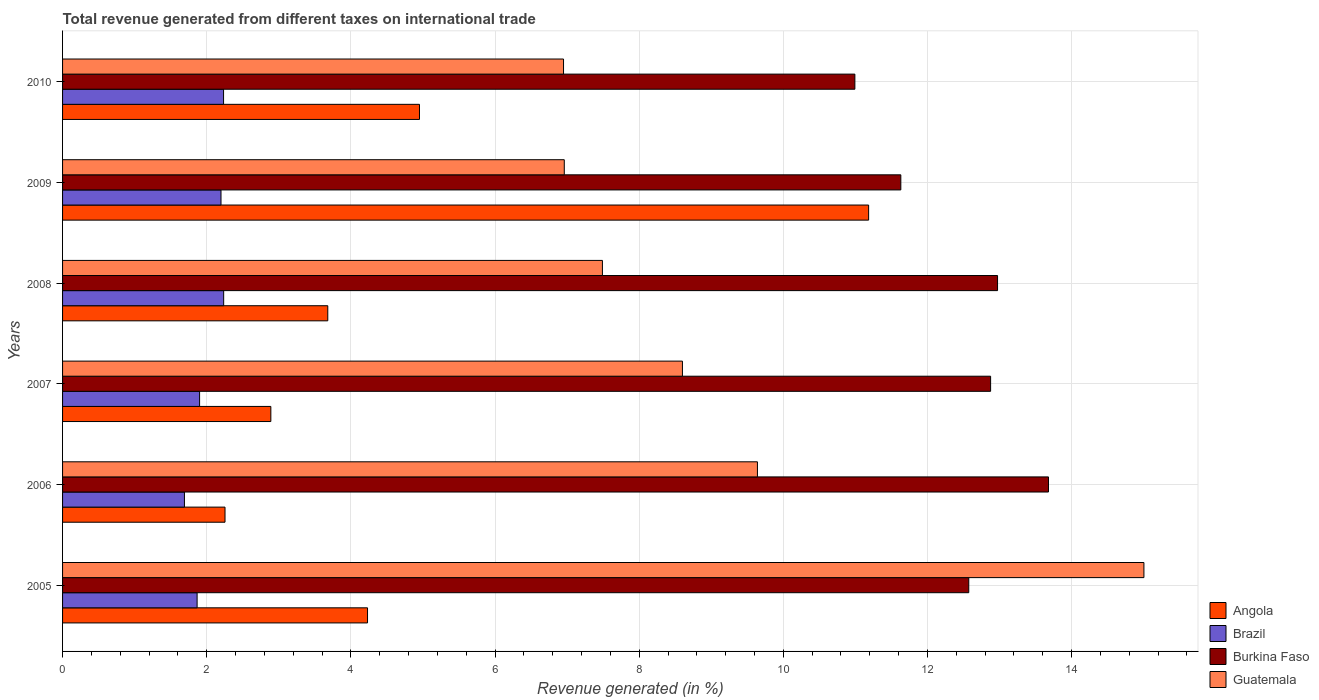How many groups of bars are there?
Your answer should be compact. 6. Are the number of bars per tick equal to the number of legend labels?
Offer a very short reply. Yes. Are the number of bars on each tick of the Y-axis equal?
Give a very brief answer. Yes. What is the label of the 6th group of bars from the top?
Ensure brevity in your answer.  2005. What is the total revenue generated in Angola in 2006?
Provide a succinct answer. 2.25. Across all years, what is the maximum total revenue generated in Brazil?
Your answer should be compact. 2.24. Across all years, what is the minimum total revenue generated in Brazil?
Provide a short and direct response. 1.69. In which year was the total revenue generated in Angola maximum?
Your answer should be very brief. 2009. In which year was the total revenue generated in Guatemala minimum?
Your answer should be very brief. 2010. What is the total total revenue generated in Guatemala in the graph?
Your answer should be very brief. 54.65. What is the difference between the total revenue generated in Angola in 2005 and that in 2007?
Your answer should be very brief. 1.34. What is the difference between the total revenue generated in Burkina Faso in 2009 and the total revenue generated in Brazil in 2008?
Make the answer very short. 9.39. What is the average total revenue generated in Burkina Faso per year?
Make the answer very short. 12.45. In the year 2009, what is the difference between the total revenue generated in Angola and total revenue generated in Burkina Faso?
Make the answer very short. -0.45. In how many years, is the total revenue generated in Brazil greater than 8.8 %?
Give a very brief answer. 0. What is the ratio of the total revenue generated in Burkina Faso in 2005 to that in 2009?
Provide a succinct answer. 1.08. Is the total revenue generated in Angola in 2006 less than that in 2009?
Your answer should be very brief. Yes. Is the difference between the total revenue generated in Angola in 2006 and 2010 greater than the difference between the total revenue generated in Burkina Faso in 2006 and 2010?
Offer a very short reply. No. What is the difference between the highest and the second highest total revenue generated in Brazil?
Offer a terse response. 0. What is the difference between the highest and the lowest total revenue generated in Angola?
Keep it short and to the point. 8.93. Is the sum of the total revenue generated in Burkina Faso in 2005 and 2008 greater than the maximum total revenue generated in Brazil across all years?
Your answer should be compact. Yes. Is it the case that in every year, the sum of the total revenue generated in Brazil and total revenue generated in Burkina Faso is greater than the sum of total revenue generated in Guatemala and total revenue generated in Angola?
Provide a succinct answer. No. What does the 2nd bar from the top in 2006 represents?
Ensure brevity in your answer.  Burkina Faso. What does the 3rd bar from the bottom in 2009 represents?
Your response must be concise. Burkina Faso. Is it the case that in every year, the sum of the total revenue generated in Angola and total revenue generated in Burkina Faso is greater than the total revenue generated in Guatemala?
Ensure brevity in your answer.  Yes. How many bars are there?
Offer a terse response. 24. Are the values on the major ticks of X-axis written in scientific E-notation?
Offer a very short reply. No. Does the graph contain any zero values?
Give a very brief answer. No. Does the graph contain grids?
Provide a succinct answer. Yes. Where does the legend appear in the graph?
Offer a very short reply. Bottom right. What is the title of the graph?
Provide a succinct answer. Total revenue generated from different taxes on international trade. What is the label or title of the X-axis?
Make the answer very short. Revenue generated (in %). What is the Revenue generated (in %) in Angola in 2005?
Make the answer very short. 4.23. What is the Revenue generated (in %) of Brazil in 2005?
Your response must be concise. 1.87. What is the Revenue generated (in %) in Burkina Faso in 2005?
Give a very brief answer. 12.57. What is the Revenue generated (in %) in Guatemala in 2005?
Keep it short and to the point. 15. What is the Revenue generated (in %) of Angola in 2006?
Your response must be concise. 2.25. What is the Revenue generated (in %) in Brazil in 2006?
Your response must be concise. 1.69. What is the Revenue generated (in %) of Burkina Faso in 2006?
Keep it short and to the point. 13.68. What is the Revenue generated (in %) in Guatemala in 2006?
Offer a very short reply. 9.64. What is the Revenue generated (in %) in Angola in 2007?
Ensure brevity in your answer.  2.89. What is the Revenue generated (in %) of Brazil in 2007?
Provide a succinct answer. 1.9. What is the Revenue generated (in %) in Burkina Faso in 2007?
Your answer should be compact. 12.88. What is the Revenue generated (in %) in Guatemala in 2007?
Your answer should be very brief. 8.6. What is the Revenue generated (in %) of Angola in 2008?
Your response must be concise. 3.68. What is the Revenue generated (in %) of Brazil in 2008?
Ensure brevity in your answer.  2.24. What is the Revenue generated (in %) of Burkina Faso in 2008?
Offer a very short reply. 12.97. What is the Revenue generated (in %) of Guatemala in 2008?
Offer a very short reply. 7.49. What is the Revenue generated (in %) in Angola in 2009?
Make the answer very short. 11.18. What is the Revenue generated (in %) in Brazil in 2009?
Offer a terse response. 2.2. What is the Revenue generated (in %) of Burkina Faso in 2009?
Your response must be concise. 11.63. What is the Revenue generated (in %) in Guatemala in 2009?
Offer a very short reply. 6.96. What is the Revenue generated (in %) of Angola in 2010?
Your answer should be very brief. 4.95. What is the Revenue generated (in %) in Brazil in 2010?
Your answer should be very brief. 2.23. What is the Revenue generated (in %) of Burkina Faso in 2010?
Give a very brief answer. 10.99. What is the Revenue generated (in %) of Guatemala in 2010?
Provide a succinct answer. 6.95. Across all years, what is the maximum Revenue generated (in %) in Angola?
Offer a terse response. 11.18. Across all years, what is the maximum Revenue generated (in %) of Brazil?
Ensure brevity in your answer.  2.24. Across all years, what is the maximum Revenue generated (in %) of Burkina Faso?
Your answer should be very brief. 13.68. Across all years, what is the maximum Revenue generated (in %) in Guatemala?
Provide a short and direct response. 15. Across all years, what is the minimum Revenue generated (in %) of Angola?
Provide a short and direct response. 2.25. Across all years, what is the minimum Revenue generated (in %) in Brazil?
Your response must be concise. 1.69. Across all years, what is the minimum Revenue generated (in %) of Burkina Faso?
Ensure brevity in your answer.  10.99. Across all years, what is the minimum Revenue generated (in %) in Guatemala?
Make the answer very short. 6.95. What is the total Revenue generated (in %) in Angola in the graph?
Offer a very short reply. 29.19. What is the total Revenue generated (in %) of Brazil in the graph?
Ensure brevity in your answer.  12.13. What is the total Revenue generated (in %) in Burkina Faso in the graph?
Provide a short and direct response. 74.72. What is the total Revenue generated (in %) in Guatemala in the graph?
Ensure brevity in your answer.  54.65. What is the difference between the Revenue generated (in %) in Angola in 2005 and that in 2006?
Keep it short and to the point. 1.98. What is the difference between the Revenue generated (in %) of Brazil in 2005 and that in 2006?
Your answer should be very brief. 0.18. What is the difference between the Revenue generated (in %) of Burkina Faso in 2005 and that in 2006?
Give a very brief answer. -1.11. What is the difference between the Revenue generated (in %) of Guatemala in 2005 and that in 2006?
Your response must be concise. 5.36. What is the difference between the Revenue generated (in %) in Angola in 2005 and that in 2007?
Your answer should be very brief. 1.34. What is the difference between the Revenue generated (in %) of Brazil in 2005 and that in 2007?
Your response must be concise. -0.03. What is the difference between the Revenue generated (in %) of Burkina Faso in 2005 and that in 2007?
Provide a short and direct response. -0.3. What is the difference between the Revenue generated (in %) of Guatemala in 2005 and that in 2007?
Your answer should be very brief. 6.4. What is the difference between the Revenue generated (in %) in Angola in 2005 and that in 2008?
Your answer should be very brief. 0.55. What is the difference between the Revenue generated (in %) of Brazil in 2005 and that in 2008?
Your answer should be compact. -0.37. What is the difference between the Revenue generated (in %) in Burkina Faso in 2005 and that in 2008?
Provide a succinct answer. -0.4. What is the difference between the Revenue generated (in %) in Guatemala in 2005 and that in 2008?
Ensure brevity in your answer.  7.51. What is the difference between the Revenue generated (in %) of Angola in 2005 and that in 2009?
Give a very brief answer. -6.95. What is the difference between the Revenue generated (in %) of Brazil in 2005 and that in 2009?
Keep it short and to the point. -0.33. What is the difference between the Revenue generated (in %) of Burkina Faso in 2005 and that in 2009?
Give a very brief answer. 0.94. What is the difference between the Revenue generated (in %) in Guatemala in 2005 and that in 2009?
Ensure brevity in your answer.  8.04. What is the difference between the Revenue generated (in %) in Angola in 2005 and that in 2010?
Offer a terse response. -0.72. What is the difference between the Revenue generated (in %) in Brazil in 2005 and that in 2010?
Your response must be concise. -0.37. What is the difference between the Revenue generated (in %) of Burkina Faso in 2005 and that in 2010?
Offer a very short reply. 1.58. What is the difference between the Revenue generated (in %) of Guatemala in 2005 and that in 2010?
Offer a terse response. 8.05. What is the difference between the Revenue generated (in %) in Angola in 2006 and that in 2007?
Make the answer very short. -0.64. What is the difference between the Revenue generated (in %) of Brazil in 2006 and that in 2007?
Make the answer very short. -0.21. What is the difference between the Revenue generated (in %) in Burkina Faso in 2006 and that in 2007?
Make the answer very short. 0.8. What is the difference between the Revenue generated (in %) in Guatemala in 2006 and that in 2007?
Your response must be concise. 1.04. What is the difference between the Revenue generated (in %) of Angola in 2006 and that in 2008?
Your response must be concise. -1.43. What is the difference between the Revenue generated (in %) of Brazil in 2006 and that in 2008?
Keep it short and to the point. -0.54. What is the difference between the Revenue generated (in %) in Burkina Faso in 2006 and that in 2008?
Your response must be concise. 0.71. What is the difference between the Revenue generated (in %) in Guatemala in 2006 and that in 2008?
Keep it short and to the point. 2.15. What is the difference between the Revenue generated (in %) in Angola in 2006 and that in 2009?
Keep it short and to the point. -8.93. What is the difference between the Revenue generated (in %) of Brazil in 2006 and that in 2009?
Your answer should be very brief. -0.51. What is the difference between the Revenue generated (in %) of Burkina Faso in 2006 and that in 2009?
Your response must be concise. 2.05. What is the difference between the Revenue generated (in %) of Guatemala in 2006 and that in 2009?
Provide a short and direct response. 2.68. What is the difference between the Revenue generated (in %) in Angola in 2006 and that in 2010?
Offer a terse response. -2.7. What is the difference between the Revenue generated (in %) in Brazil in 2006 and that in 2010?
Offer a terse response. -0.54. What is the difference between the Revenue generated (in %) of Burkina Faso in 2006 and that in 2010?
Provide a succinct answer. 2.69. What is the difference between the Revenue generated (in %) of Guatemala in 2006 and that in 2010?
Make the answer very short. 2.69. What is the difference between the Revenue generated (in %) in Angola in 2007 and that in 2008?
Your answer should be very brief. -0.79. What is the difference between the Revenue generated (in %) in Brazil in 2007 and that in 2008?
Give a very brief answer. -0.33. What is the difference between the Revenue generated (in %) of Burkina Faso in 2007 and that in 2008?
Give a very brief answer. -0.1. What is the difference between the Revenue generated (in %) in Guatemala in 2007 and that in 2008?
Give a very brief answer. 1.11. What is the difference between the Revenue generated (in %) in Angola in 2007 and that in 2009?
Make the answer very short. -8.29. What is the difference between the Revenue generated (in %) of Brazil in 2007 and that in 2009?
Keep it short and to the point. -0.3. What is the difference between the Revenue generated (in %) of Burkina Faso in 2007 and that in 2009?
Provide a succinct answer. 1.25. What is the difference between the Revenue generated (in %) of Guatemala in 2007 and that in 2009?
Make the answer very short. 1.64. What is the difference between the Revenue generated (in %) in Angola in 2007 and that in 2010?
Give a very brief answer. -2.06. What is the difference between the Revenue generated (in %) of Brazil in 2007 and that in 2010?
Keep it short and to the point. -0.33. What is the difference between the Revenue generated (in %) of Burkina Faso in 2007 and that in 2010?
Your answer should be very brief. 1.88. What is the difference between the Revenue generated (in %) of Guatemala in 2007 and that in 2010?
Make the answer very short. 1.65. What is the difference between the Revenue generated (in %) in Angola in 2008 and that in 2009?
Make the answer very short. -7.5. What is the difference between the Revenue generated (in %) in Brazil in 2008 and that in 2009?
Keep it short and to the point. 0.04. What is the difference between the Revenue generated (in %) in Burkina Faso in 2008 and that in 2009?
Keep it short and to the point. 1.34. What is the difference between the Revenue generated (in %) of Guatemala in 2008 and that in 2009?
Provide a succinct answer. 0.53. What is the difference between the Revenue generated (in %) in Angola in 2008 and that in 2010?
Ensure brevity in your answer.  -1.27. What is the difference between the Revenue generated (in %) in Brazil in 2008 and that in 2010?
Your answer should be compact. 0. What is the difference between the Revenue generated (in %) of Burkina Faso in 2008 and that in 2010?
Provide a succinct answer. 1.98. What is the difference between the Revenue generated (in %) of Guatemala in 2008 and that in 2010?
Give a very brief answer. 0.54. What is the difference between the Revenue generated (in %) of Angola in 2009 and that in 2010?
Ensure brevity in your answer.  6.23. What is the difference between the Revenue generated (in %) of Brazil in 2009 and that in 2010?
Provide a succinct answer. -0.04. What is the difference between the Revenue generated (in %) of Burkina Faso in 2009 and that in 2010?
Ensure brevity in your answer.  0.64. What is the difference between the Revenue generated (in %) of Guatemala in 2009 and that in 2010?
Provide a succinct answer. 0.01. What is the difference between the Revenue generated (in %) in Angola in 2005 and the Revenue generated (in %) in Brazil in 2006?
Provide a short and direct response. 2.54. What is the difference between the Revenue generated (in %) in Angola in 2005 and the Revenue generated (in %) in Burkina Faso in 2006?
Offer a terse response. -9.45. What is the difference between the Revenue generated (in %) of Angola in 2005 and the Revenue generated (in %) of Guatemala in 2006?
Provide a succinct answer. -5.41. What is the difference between the Revenue generated (in %) of Brazil in 2005 and the Revenue generated (in %) of Burkina Faso in 2006?
Offer a terse response. -11.81. What is the difference between the Revenue generated (in %) in Brazil in 2005 and the Revenue generated (in %) in Guatemala in 2006?
Provide a short and direct response. -7.77. What is the difference between the Revenue generated (in %) in Burkina Faso in 2005 and the Revenue generated (in %) in Guatemala in 2006?
Ensure brevity in your answer.  2.93. What is the difference between the Revenue generated (in %) of Angola in 2005 and the Revenue generated (in %) of Brazil in 2007?
Your answer should be compact. 2.33. What is the difference between the Revenue generated (in %) of Angola in 2005 and the Revenue generated (in %) of Burkina Faso in 2007?
Give a very brief answer. -8.64. What is the difference between the Revenue generated (in %) of Angola in 2005 and the Revenue generated (in %) of Guatemala in 2007?
Provide a succinct answer. -4.37. What is the difference between the Revenue generated (in %) of Brazil in 2005 and the Revenue generated (in %) of Burkina Faso in 2007?
Provide a succinct answer. -11.01. What is the difference between the Revenue generated (in %) of Brazil in 2005 and the Revenue generated (in %) of Guatemala in 2007?
Provide a short and direct response. -6.73. What is the difference between the Revenue generated (in %) in Burkina Faso in 2005 and the Revenue generated (in %) in Guatemala in 2007?
Ensure brevity in your answer.  3.97. What is the difference between the Revenue generated (in %) of Angola in 2005 and the Revenue generated (in %) of Brazil in 2008?
Provide a short and direct response. 2. What is the difference between the Revenue generated (in %) of Angola in 2005 and the Revenue generated (in %) of Burkina Faso in 2008?
Ensure brevity in your answer.  -8.74. What is the difference between the Revenue generated (in %) of Angola in 2005 and the Revenue generated (in %) of Guatemala in 2008?
Keep it short and to the point. -3.26. What is the difference between the Revenue generated (in %) in Brazil in 2005 and the Revenue generated (in %) in Burkina Faso in 2008?
Your answer should be very brief. -11.11. What is the difference between the Revenue generated (in %) in Brazil in 2005 and the Revenue generated (in %) in Guatemala in 2008?
Provide a succinct answer. -5.62. What is the difference between the Revenue generated (in %) of Burkina Faso in 2005 and the Revenue generated (in %) of Guatemala in 2008?
Your answer should be very brief. 5.08. What is the difference between the Revenue generated (in %) in Angola in 2005 and the Revenue generated (in %) in Brazil in 2009?
Make the answer very short. 2.03. What is the difference between the Revenue generated (in %) of Angola in 2005 and the Revenue generated (in %) of Burkina Faso in 2009?
Provide a short and direct response. -7.4. What is the difference between the Revenue generated (in %) in Angola in 2005 and the Revenue generated (in %) in Guatemala in 2009?
Keep it short and to the point. -2.73. What is the difference between the Revenue generated (in %) in Brazil in 2005 and the Revenue generated (in %) in Burkina Faso in 2009?
Your answer should be compact. -9.76. What is the difference between the Revenue generated (in %) in Brazil in 2005 and the Revenue generated (in %) in Guatemala in 2009?
Keep it short and to the point. -5.09. What is the difference between the Revenue generated (in %) in Burkina Faso in 2005 and the Revenue generated (in %) in Guatemala in 2009?
Ensure brevity in your answer.  5.61. What is the difference between the Revenue generated (in %) of Angola in 2005 and the Revenue generated (in %) of Brazil in 2010?
Your response must be concise. 2. What is the difference between the Revenue generated (in %) of Angola in 2005 and the Revenue generated (in %) of Burkina Faso in 2010?
Your answer should be very brief. -6.76. What is the difference between the Revenue generated (in %) in Angola in 2005 and the Revenue generated (in %) in Guatemala in 2010?
Keep it short and to the point. -2.72. What is the difference between the Revenue generated (in %) in Brazil in 2005 and the Revenue generated (in %) in Burkina Faso in 2010?
Offer a very short reply. -9.13. What is the difference between the Revenue generated (in %) in Brazil in 2005 and the Revenue generated (in %) in Guatemala in 2010?
Your answer should be very brief. -5.08. What is the difference between the Revenue generated (in %) of Burkina Faso in 2005 and the Revenue generated (in %) of Guatemala in 2010?
Provide a succinct answer. 5.62. What is the difference between the Revenue generated (in %) in Angola in 2006 and the Revenue generated (in %) in Brazil in 2007?
Keep it short and to the point. 0.35. What is the difference between the Revenue generated (in %) of Angola in 2006 and the Revenue generated (in %) of Burkina Faso in 2007?
Give a very brief answer. -10.62. What is the difference between the Revenue generated (in %) in Angola in 2006 and the Revenue generated (in %) in Guatemala in 2007?
Keep it short and to the point. -6.35. What is the difference between the Revenue generated (in %) of Brazil in 2006 and the Revenue generated (in %) of Burkina Faso in 2007?
Provide a succinct answer. -11.18. What is the difference between the Revenue generated (in %) of Brazil in 2006 and the Revenue generated (in %) of Guatemala in 2007?
Your answer should be compact. -6.91. What is the difference between the Revenue generated (in %) of Burkina Faso in 2006 and the Revenue generated (in %) of Guatemala in 2007?
Offer a terse response. 5.08. What is the difference between the Revenue generated (in %) of Angola in 2006 and the Revenue generated (in %) of Brazil in 2008?
Ensure brevity in your answer.  0.02. What is the difference between the Revenue generated (in %) in Angola in 2006 and the Revenue generated (in %) in Burkina Faso in 2008?
Provide a succinct answer. -10.72. What is the difference between the Revenue generated (in %) in Angola in 2006 and the Revenue generated (in %) in Guatemala in 2008?
Offer a very short reply. -5.24. What is the difference between the Revenue generated (in %) of Brazil in 2006 and the Revenue generated (in %) of Burkina Faso in 2008?
Offer a very short reply. -11.28. What is the difference between the Revenue generated (in %) in Brazil in 2006 and the Revenue generated (in %) in Guatemala in 2008?
Offer a very short reply. -5.8. What is the difference between the Revenue generated (in %) in Burkina Faso in 2006 and the Revenue generated (in %) in Guatemala in 2008?
Keep it short and to the point. 6.19. What is the difference between the Revenue generated (in %) of Angola in 2006 and the Revenue generated (in %) of Brazil in 2009?
Ensure brevity in your answer.  0.06. What is the difference between the Revenue generated (in %) in Angola in 2006 and the Revenue generated (in %) in Burkina Faso in 2009?
Ensure brevity in your answer.  -9.38. What is the difference between the Revenue generated (in %) of Angola in 2006 and the Revenue generated (in %) of Guatemala in 2009?
Provide a short and direct response. -4.71. What is the difference between the Revenue generated (in %) of Brazil in 2006 and the Revenue generated (in %) of Burkina Faso in 2009?
Your answer should be compact. -9.94. What is the difference between the Revenue generated (in %) of Brazil in 2006 and the Revenue generated (in %) of Guatemala in 2009?
Your answer should be compact. -5.27. What is the difference between the Revenue generated (in %) of Burkina Faso in 2006 and the Revenue generated (in %) of Guatemala in 2009?
Provide a short and direct response. 6.72. What is the difference between the Revenue generated (in %) in Angola in 2006 and the Revenue generated (in %) in Brazil in 2010?
Offer a terse response. 0.02. What is the difference between the Revenue generated (in %) of Angola in 2006 and the Revenue generated (in %) of Burkina Faso in 2010?
Provide a succinct answer. -8.74. What is the difference between the Revenue generated (in %) in Angola in 2006 and the Revenue generated (in %) in Guatemala in 2010?
Provide a short and direct response. -4.7. What is the difference between the Revenue generated (in %) in Brazil in 2006 and the Revenue generated (in %) in Burkina Faso in 2010?
Give a very brief answer. -9.3. What is the difference between the Revenue generated (in %) of Brazil in 2006 and the Revenue generated (in %) of Guatemala in 2010?
Your answer should be compact. -5.26. What is the difference between the Revenue generated (in %) in Burkina Faso in 2006 and the Revenue generated (in %) in Guatemala in 2010?
Your answer should be compact. 6.73. What is the difference between the Revenue generated (in %) in Angola in 2007 and the Revenue generated (in %) in Brazil in 2008?
Make the answer very short. 0.65. What is the difference between the Revenue generated (in %) in Angola in 2007 and the Revenue generated (in %) in Burkina Faso in 2008?
Provide a succinct answer. -10.08. What is the difference between the Revenue generated (in %) in Angola in 2007 and the Revenue generated (in %) in Guatemala in 2008?
Offer a very short reply. -4.6. What is the difference between the Revenue generated (in %) of Brazil in 2007 and the Revenue generated (in %) of Burkina Faso in 2008?
Keep it short and to the point. -11.07. What is the difference between the Revenue generated (in %) in Brazil in 2007 and the Revenue generated (in %) in Guatemala in 2008?
Provide a short and direct response. -5.59. What is the difference between the Revenue generated (in %) in Burkina Faso in 2007 and the Revenue generated (in %) in Guatemala in 2008?
Ensure brevity in your answer.  5.39. What is the difference between the Revenue generated (in %) in Angola in 2007 and the Revenue generated (in %) in Brazil in 2009?
Provide a succinct answer. 0.69. What is the difference between the Revenue generated (in %) in Angola in 2007 and the Revenue generated (in %) in Burkina Faso in 2009?
Keep it short and to the point. -8.74. What is the difference between the Revenue generated (in %) of Angola in 2007 and the Revenue generated (in %) of Guatemala in 2009?
Your response must be concise. -4.07. What is the difference between the Revenue generated (in %) of Brazil in 2007 and the Revenue generated (in %) of Burkina Faso in 2009?
Your answer should be very brief. -9.73. What is the difference between the Revenue generated (in %) of Brazil in 2007 and the Revenue generated (in %) of Guatemala in 2009?
Offer a terse response. -5.06. What is the difference between the Revenue generated (in %) in Burkina Faso in 2007 and the Revenue generated (in %) in Guatemala in 2009?
Make the answer very short. 5.91. What is the difference between the Revenue generated (in %) in Angola in 2007 and the Revenue generated (in %) in Brazil in 2010?
Your response must be concise. 0.66. What is the difference between the Revenue generated (in %) of Angola in 2007 and the Revenue generated (in %) of Burkina Faso in 2010?
Provide a short and direct response. -8.1. What is the difference between the Revenue generated (in %) in Angola in 2007 and the Revenue generated (in %) in Guatemala in 2010?
Make the answer very short. -4.06. What is the difference between the Revenue generated (in %) in Brazil in 2007 and the Revenue generated (in %) in Burkina Faso in 2010?
Your answer should be very brief. -9.09. What is the difference between the Revenue generated (in %) in Brazil in 2007 and the Revenue generated (in %) in Guatemala in 2010?
Give a very brief answer. -5.05. What is the difference between the Revenue generated (in %) of Burkina Faso in 2007 and the Revenue generated (in %) of Guatemala in 2010?
Provide a succinct answer. 5.93. What is the difference between the Revenue generated (in %) of Angola in 2008 and the Revenue generated (in %) of Brazil in 2009?
Your answer should be compact. 1.48. What is the difference between the Revenue generated (in %) of Angola in 2008 and the Revenue generated (in %) of Burkina Faso in 2009?
Your answer should be very brief. -7.95. What is the difference between the Revenue generated (in %) in Angola in 2008 and the Revenue generated (in %) in Guatemala in 2009?
Provide a succinct answer. -3.28. What is the difference between the Revenue generated (in %) in Brazil in 2008 and the Revenue generated (in %) in Burkina Faso in 2009?
Provide a short and direct response. -9.39. What is the difference between the Revenue generated (in %) in Brazil in 2008 and the Revenue generated (in %) in Guatemala in 2009?
Offer a very short reply. -4.73. What is the difference between the Revenue generated (in %) of Burkina Faso in 2008 and the Revenue generated (in %) of Guatemala in 2009?
Offer a very short reply. 6.01. What is the difference between the Revenue generated (in %) of Angola in 2008 and the Revenue generated (in %) of Brazil in 2010?
Keep it short and to the point. 1.45. What is the difference between the Revenue generated (in %) in Angola in 2008 and the Revenue generated (in %) in Burkina Faso in 2010?
Your response must be concise. -7.31. What is the difference between the Revenue generated (in %) of Angola in 2008 and the Revenue generated (in %) of Guatemala in 2010?
Ensure brevity in your answer.  -3.27. What is the difference between the Revenue generated (in %) of Brazil in 2008 and the Revenue generated (in %) of Burkina Faso in 2010?
Provide a short and direct response. -8.76. What is the difference between the Revenue generated (in %) of Brazil in 2008 and the Revenue generated (in %) of Guatemala in 2010?
Your response must be concise. -4.72. What is the difference between the Revenue generated (in %) in Burkina Faso in 2008 and the Revenue generated (in %) in Guatemala in 2010?
Keep it short and to the point. 6.02. What is the difference between the Revenue generated (in %) of Angola in 2009 and the Revenue generated (in %) of Brazil in 2010?
Make the answer very short. 8.95. What is the difference between the Revenue generated (in %) of Angola in 2009 and the Revenue generated (in %) of Burkina Faso in 2010?
Your response must be concise. 0.19. What is the difference between the Revenue generated (in %) of Angola in 2009 and the Revenue generated (in %) of Guatemala in 2010?
Ensure brevity in your answer.  4.23. What is the difference between the Revenue generated (in %) of Brazil in 2009 and the Revenue generated (in %) of Burkina Faso in 2010?
Give a very brief answer. -8.79. What is the difference between the Revenue generated (in %) of Brazil in 2009 and the Revenue generated (in %) of Guatemala in 2010?
Provide a succinct answer. -4.75. What is the difference between the Revenue generated (in %) in Burkina Faso in 2009 and the Revenue generated (in %) in Guatemala in 2010?
Keep it short and to the point. 4.68. What is the average Revenue generated (in %) in Angola per year?
Provide a succinct answer. 4.87. What is the average Revenue generated (in %) in Brazil per year?
Give a very brief answer. 2.02. What is the average Revenue generated (in %) of Burkina Faso per year?
Provide a short and direct response. 12.45. What is the average Revenue generated (in %) in Guatemala per year?
Your answer should be compact. 9.11. In the year 2005, what is the difference between the Revenue generated (in %) in Angola and Revenue generated (in %) in Brazil?
Offer a terse response. 2.36. In the year 2005, what is the difference between the Revenue generated (in %) in Angola and Revenue generated (in %) in Burkina Faso?
Offer a terse response. -8.34. In the year 2005, what is the difference between the Revenue generated (in %) of Angola and Revenue generated (in %) of Guatemala?
Offer a very short reply. -10.77. In the year 2005, what is the difference between the Revenue generated (in %) of Brazil and Revenue generated (in %) of Burkina Faso?
Offer a terse response. -10.71. In the year 2005, what is the difference between the Revenue generated (in %) of Brazil and Revenue generated (in %) of Guatemala?
Ensure brevity in your answer.  -13.14. In the year 2005, what is the difference between the Revenue generated (in %) in Burkina Faso and Revenue generated (in %) in Guatemala?
Provide a succinct answer. -2.43. In the year 2006, what is the difference between the Revenue generated (in %) of Angola and Revenue generated (in %) of Brazil?
Ensure brevity in your answer.  0.56. In the year 2006, what is the difference between the Revenue generated (in %) in Angola and Revenue generated (in %) in Burkina Faso?
Offer a terse response. -11.42. In the year 2006, what is the difference between the Revenue generated (in %) in Angola and Revenue generated (in %) in Guatemala?
Your response must be concise. -7.39. In the year 2006, what is the difference between the Revenue generated (in %) of Brazil and Revenue generated (in %) of Burkina Faso?
Provide a short and direct response. -11.99. In the year 2006, what is the difference between the Revenue generated (in %) of Brazil and Revenue generated (in %) of Guatemala?
Your answer should be compact. -7.95. In the year 2006, what is the difference between the Revenue generated (in %) in Burkina Faso and Revenue generated (in %) in Guatemala?
Make the answer very short. 4.04. In the year 2007, what is the difference between the Revenue generated (in %) in Angola and Revenue generated (in %) in Burkina Faso?
Provide a succinct answer. -9.99. In the year 2007, what is the difference between the Revenue generated (in %) of Angola and Revenue generated (in %) of Guatemala?
Provide a short and direct response. -5.71. In the year 2007, what is the difference between the Revenue generated (in %) in Brazil and Revenue generated (in %) in Burkina Faso?
Give a very brief answer. -10.97. In the year 2007, what is the difference between the Revenue generated (in %) of Brazil and Revenue generated (in %) of Guatemala?
Make the answer very short. -6.7. In the year 2007, what is the difference between the Revenue generated (in %) in Burkina Faso and Revenue generated (in %) in Guatemala?
Provide a short and direct response. 4.28. In the year 2008, what is the difference between the Revenue generated (in %) in Angola and Revenue generated (in %) in Brazil?
Provide a short and direct response. 1.44. In the year 2008, what is the difference between the Revenue generated (in %) in Angola and Revenue generated (in %) in Burkina Faso?
Your answer should be very brief. -9.29. In the year 2008, what is the difference between the Revenue generated (in %) in Angola and Revenue generated (in %) in Guatemala?
Provide a short and direct response. -3.81. In the year 2008, what is the difference between the Revenue generated (in %) in Brazil and Revenue generated (in %) in Burkina Faso?
Your answer should be compact. -10.74. In the year 2008, what is the difference between the Revenue generated (in %) in Brazil and Revenue generated (in %) in Guatemala?
Provide a short and direct response. -5.25. In the year 2008, what is the difference between the Revenue generated (in %) in Burkina Faso and Revenue generated (in %) in Guatemala?
Your answer should be very brief. 5.48. In the year 2009, what is the difference between the Revenue generated (in %) in Angola and Revenue generated (in %) in Brazil?
Offer a very short reply. 8.99. In the year 2009, what is the difference between the Revenue generated (in %) in Angola and Revenue generated (in %) in Burkina Faso?
Offer a terse response. -0.45. In the year 2009, what is the difference between the Revenue generated (in %) in Angola and Revenue generated (in %) in Guatemala?
Offer a terse response. 4.22. In the year 2009, what is the difference between the Revenue generated (in %) in Brazil and Revenue generated (in %) in Burkina Faso?
Make the answer very short. -9.43. In the year 2009, what is the difference between the Revenue generated (in %) of Brazil and Revenue generated (in %) of Guatemala?
Ensure brevity in your answer.  -4.76. In the year 2009, what is the difference between the Revenue generated (in %) of Burkina Faso and Revenue generated (in %) of Guatemala?
Make the answer very short. 4.67. In the year 2010, what is the difference between the Revenue generated (in %) of Angola and Revenue generated (in %) of Brazil?
Make the answer very short. 2.72. In the year 2010, what is the difference between the Revenue generated (in %) in Angola and Revenue generated (in %) in Burkina Faso?
Your response must be concise. -6.04. In the year 2010, what is the difference between the Revenue generated (in %) in Angola and Revenue generated (in %) in Guatemala?
Make the answer very short. -2. In the year 2010, what is the difference between the Revenue generated (in %) of Brazil and Revenue generated (in %) of Burkina Faso?
Provide a short and direct response. -8.76. In the year 2010, what is the difference between the Revenue generated (in %) in Brazil and Revenue generated (in %) in Guatemala?
Provide a succinct answer. -4.72. In the year 2010, what is the difference between the Revenue generated (in %) of Burkina Faso and Revenue generated (in %) of Guatemala?
Make the answer very short. 4.04. What is the ratio of the Revenue generated (in %) in Angola in 2005 to that in 2006?
Your response must be concise. 1.88. What is the ratio of the Revenue generated (in %) in Brazil in 2005 to that in 2006?
Ensure brevity in your answer.  1.1. What is the ratio of the Revenue generated (in %) in Burkina Faso in 2005 to that in 2006?
Your response must be concise. 0.92. What is the ratio of the Revenue generated (in %) of Guatemala in 2005 to that in 2006?
Your answer should be compact. 1.56. What is the ratio of the Revenue generated (in %) of Angola in 2005 to that in 2007?
Make the answer very short. 1.46. What is the ratio of the Revenue generated (in %) of Brazil in 2005 to that in 2007?
Offer a terse response. 0.98. What is the ratio of the Revenue generated (in %) of Burkina Faso in 2005 to that in 2007?
Your answer should be compact. 0.98. What is the ratio of the Revenue generated (in %) of Guatemala in 2005 to that in 2007?
Make the answer very short. 1.74. What is the ratio of the Revenue generated (in %) of Angola in 2005 to that in 2008?
Make the answer very short. 1.15. What is the ratio of the Revenue generated (in %) in Brazil in 2005 to that in 2008?
Your answer should be very brief. 0.84. What is the ratio of the Revenue generated (in %) in Burkina Faso in 2005 to that in 2008?
Offer a very short reply. 0.97. What is the ratio of the Revenue generated (in %) in Guatemala in 2005 to that in 2008?
Keep it short and to the point. 2. What is the ratio of the Revenue generated (in %) in Angola in 2005 to that in 2009?
Your answer should be very brief. 0.38. What is the ratio of the Revenue generated (in %) of Brazil in 2005 to that in 2009?
Keep it short and to the point. 0.85. What is the ratio of the Revenue generated (in %) of Burkina Faso in 2005 to that in 2009?
Ensure brevity in your answer.  1.08. What is the ratio of the Revenue generated (in %) in Guatemala in 2005 to that in 2009?
Offer a very short reply. 2.16. What is the ratio of the Revenue generated (in %) in Angola in 2005 to that in 2010?
Your answer should be very brief. 0.85. What is the ratio of the Revenue generated (in %) of Brazil in 2005 to that in 2010?
Provide a short and direct response. 0.84. What is the ratio of the Revenue generated (in %) in Burkina Faso in 2005 to that in 2010?
Make the answer very short. 1.14. What is the ratio of the Revenue generated (in %) in Guatemala in 2005 to that in 2010?
Your response must be concise. 2.16. What is the ratio of the Revenue generated (in %) in Angola in 2006 to that in 2007?
Provide a short and direct response. 0.78. What is the ratio of the Revenue generated (in %) in Brazil in 2006 to that in 2007?
Your answer should be very brief. 0.89. What is the ratio of the Revenue generated (in %) in Burkina Faso in 2006 to that in 2007?
Give a very brief answer. 1.06. What is the ratio of the Revenue generated (in %) of Guatemala in 2006 to that in 2007?
Your answer should be very brief. 1.12. What is the ratio of the Revenue generated (in %) in Angola in 2006 to that in 2008?
Offer a terse response. 0.61. What is the ratio of the Revenue generated (in %) of Brazil in 2006 to that in 2008?
Provide a short and direct response. 0.76. What is the ratio of the Revenue generated (in %) in Burkina Faso in 2006 to that in 2008?
Give a very brief answer. 1.05. What is the ratio of the Revenue generated (in %) in Guatemala in 2006 to that in 2008?
Your answer should be compact. 1.29. What is the ratio of the Revenue generated (in %) in Angola in 2006 to that in 2009?
Keep it short and to the point. 0.2. What is the ratio of the Revenue generated (in %) in Brazil in 2006 to that in 2009?
Make the answer very short. 0.77. What is the ratio of the Revenue generated (in %) in Burkina Faso in 2006 to that in 2009?
Your response must be concise. 1.18. What is the ratio of the Revenue generated (in %) of Guatemala in 2006 to that in 2009?
Keep it short and to the point. 1.39. What is the ratio of the Revenue generated (in %) in Angola in 2006 to that in 2010?
Offer a very short reply. 0.46. What is the ratio of the Revenue generated (in %) of Brazil in 2006 to that in 2010?
Your response must be concise. 0.76. What is the ratio of the Revenue generated (in %) in Burkina Faso in 2006 to that in 2010?
Offer a terse response. 1.24. What is the ratio of the Revenue generated (in %) in Guatemala in 2006 to that in 2010?
Provide a short and direct response. 1.39. What is the ratio of the Revenue generated (in %) in Angola in 2007 to that in 2008?
Ensure brevity in your answer.  0.79. What is the ratio of the Revenue generated (in %) of Brazil in 2007 to that in 2008?
Your answer should be compact. 0.85. What is the ratio of the Revenue generated (in %) in Burkina Faso in 2007 to that in 2008?
Your answer should be compact. 0.99. What is the ratio of the Revenue generated (in %) of Guatemala in 2007 to that in 2008?
Ensure brevity in your answer.  1.15. What is the ratio of the Revenue generated (in %) of Angola in 2007 to that in 2009?
Your answer should be very brief. 0.26. What is the ratio of the Revenue generated (in %) in Brazil in 2007 to that in 2009?
Provide a short and direct response. 0.86. What is the ratio of the Revenue generated (in %) in Burkina Faso in 2007 to that in 2009?
Provide a succinct answer. 1.11. What is the ratio of the Revenue generated (in %) in Guatemala in 2007 to that in 2009?
Your response must be concise. 1.24. What is the ratio of the Revenue generated (in %) of Angola in 2007 to that in 2010?
Offer a very short reply. 0.58. What is the ratio of the Revenue generated (in %) in Brazil in 2007 to that in 2010?
Offer a terse response. 0.85. What is the ratio of the Revenue generated (in %) of Burkina Faso in 2007 to that in 2010?
Ensure brevity in your answer.  1.17. What is the ratio of the Revenue generated (in %) of Guatemala in 2007 to that in 2010?
Provide a short and direct response. 1.24. What is the ratio of the Revenue generated (in %) of Angola in 2008 to that in 2009?
Make the answer very short. 0.33. What is the ratio of the Revenue generated (in %) of Brazil in 2008 to that in 2009?
Provide a succinct answer. 1.02. What is the ratio of the Revenue generated (in %) of Burkina Faso in 2008 to that in 2009?
Provide a succinct answer. 1.12. What is the ratio of the Revenue generated (in %) of Guatemala in 2008 to that in 2009?
Provide a short and direct response. 1.08. What is the ratio of the Revenue generated (in %) of Angola in 2008 to that in 2010?
Give a very brief answer. 0.74. What is the ratio of the Revenue generated (in %) of Brazil in 2008 to that in 2010?
Give a very brief answer. 1. What is the ratio of the Revenue generated (in %) of Burkina Faso in 2008 to that in 2010?
Your answer should be compact. 1.18. What is the ratio of the Revenue generated (in %) of Guatemala in 2008 to that in 2010?
Keep it short and to the point. 1.08. What is the ratio of the Revenue generated (in %) in Angola in 2009 to that in 2010?
Your answer should be very brief. 2.26. What is the ratio of the Revenue generated (in %) of Brazil in 2009 to that in 2010?
Give a very brief answer. 0.98. What is the ratio of the Revenue generated (in %) in Burkina Faso in 2009 to that in 2010?
Your response must be concise. 1.06. What is the ratio of the Revenue generated (in %) in Guatemala in 2009 to that in 2010?
Your response must be concise. 1. What is the difference between the highest and the second highest Revenue generated (in %) in Angola?
Keep it short and to the point. 6.23. What is the difference between the highest and the second highest Revenue generated (in %) of Brazil?
Provide a succinct answer. 0. What is the difference between the highest and the second highest Revenue generated (in %) of Burkina Faso?
Provide a short and direct response. 0.71. What is the difference between the highest and the second highest Revenue generated (in %) of Guatemala?
Make the answer very short. 5.36. What is the difference between the highest and the lowest Revenue generated (in %) in Angola?
Keep it short and to the point. 8.93. What is the difference between the highest and the lowest Revenue generated (in %) in Brazil?
Provide a short and direct response. 0.54. What is the difference between the highest and the lowest Revenue generated (in %) of Burkina Faso?
Offer a very short reply. 2.69. What is the difference between the highest and the lowest Revenue generated (in %) in Guatemala?
Your answer should be compact. 8.05. 